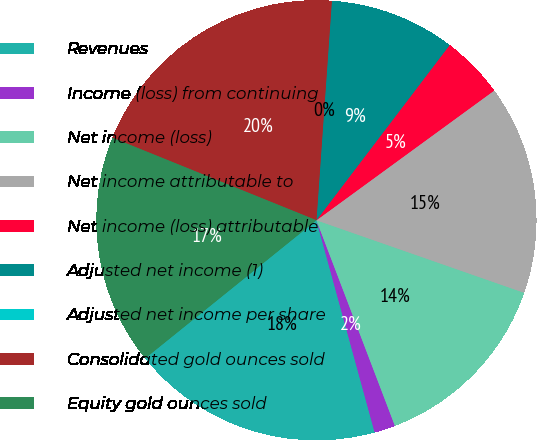Convert chart to OTSL. <chart><loc_0><loc_0><loc_500><loc_500><pie_chart><fcel>Revenues<fcel>Income (loss) from continuing<fcel>Net income (loss)<fcel>Net income attributable to<fcel>Net income (loss) attributable<fcel>Adjusted net income (1)<fcel>Adjusted net income per share<fcel>Consolidated gold ounces sold<fcel>Equity gold ounces sold<nl><fcel>18.46%<fcel>1.54%<fcel>13.85%<fcel>15.38%<fcel>4.62%<fcel>9.23%<fcel>0.0%<fcel>20.0%<fcel>16.92%<nl></chart> 